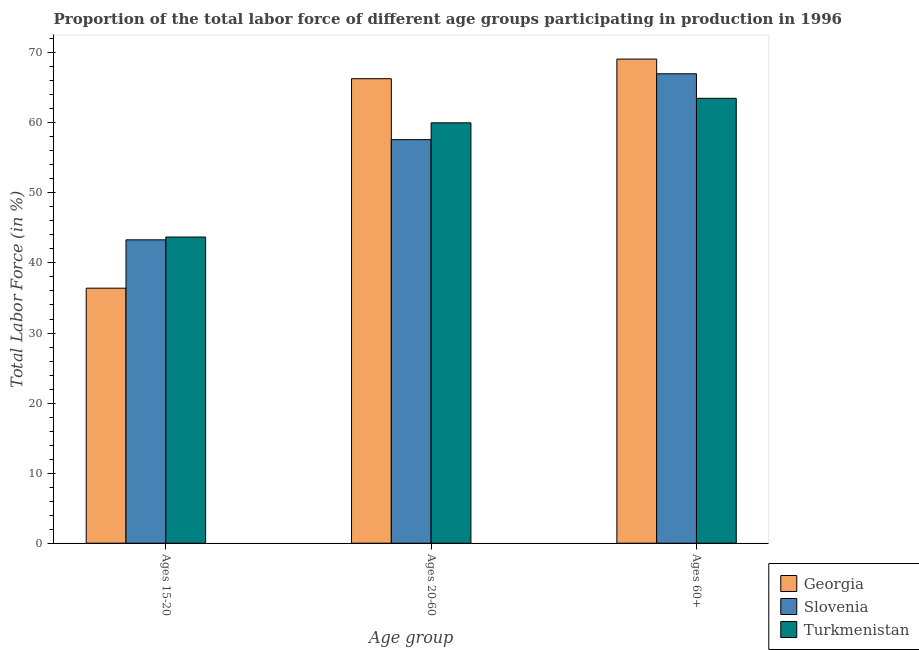How many bars are there on the 2nd tick from the left?
Give a very brief answer. 3. What is the label of the 1st group of bars from the left?
Keep it short and to the point. Ages 15-20. What is the percentage of labor force above age 60 in Turkmenistan?
Your answer should be very brief. 63.5. Across all countries, what is the maximum percentage of labor force within the age group 20-60?
Provide a succinct answer. 66.3. Across all countries, what is the minimum percentage of labor force within the age group 15-20?
Offer a very short reply. 36.4. In which country was the percentage of labor force within the age group 20-60 maximum?
Your answer should be very brief. Georgia. In which country was the percentage of labor force above age 60 minimum?
Provide a short and direct response. Turkmenistan. What is the total percentage of labor force above age 60 in the graph?
Keep it short and to the point. 199.6. What is the difference between the percentage of labor force within the age group 15-20 in Turkmenistan and that in Georgia?
Give a very brief answer. 7.3. What is the difference between the percentage of labor force within the age group 15-20 in Georgia and the percentage of labor force above age 60 in Turkmenistan?
Provide a short and direct response. -27.1. What is the average percentage of labor force within the age group 20-60 per country?
Keep it short and to the point. 61.3. What is the ratio of the percentage of labor force above age 60 in Slovenia to that in Turkmenistan?
Offer a terse response. 1.06. What is the difference between the highest and the second highest percentage of labor force within the age group 20-60?
Your answer should be compact. 6.3. What is the difference between the highest and the lowest percentage of labor force above age 60?
Your answer should be very brief. 5.6. Is the sum of the percentage of labor force within the age group 15-20 in Turkmenistan and Georgia greater than the maximum percentage of labor force within the age group 20-60 across all countries?
Offer a very short reply. Yes. What does the 3rd bar from the left in Ages 20-60 represents?
Make the answer very short. Turkmenistan. What does the 1st bar from the right in Ages 60+ represents?
Make the answer very short. Turkmenistan. Is it the case that in every country, the sum of the percentage of labor force within the age group 15-20 and percentage of labor force within the age group 20-60 is greater than the percentage of labor force above age 60?
Offer a very short reply. Yes. How many bars are there?
Your answer should be very brief. 9. How many countries are there in the graph?
Your response must be concise. 3. Are the values on the major ticks of Y-axis written in scientific E-notation?
Offer a very short reply. No. Does the graph contain any zero values?
Offer a very short reply. No. Does the graph contain grids?
Your answer should be very brief. No. How are the legend labels stacked?
Keep it short and to the point. Vertical. What is the title of the graph?
Ensure brevity in your answer.  Proportion of the total labor force of different age groups participating in production in 1996. Does "Other small states" appear as one of the legend labels in the graph?
Ensure brevity in your answer.  No. What is the label or title of the X-axis?
Your answer should be compact. Age group. What is the label or title of the Y-axis?
Your response must be concise. Total Labor Force (in %). What is the Total Labor Force (in %) of Georgia in Ages 15-20?
Give a very brief answer. 36.4. What is the Total Labor Force (in %) of Slovenia in Ages 15-20?
Offer a very short reply. 43.3. What is the Total Labor Force (in %) of Turkmenistan in Ages 15-20?
Offer a terse response. 43.7. What is the Total Labor Force (in %) of Georgia in Ages 20-60?
Provide a succinct answer. 66.3. What is the Total Labor Force (in %) of Slovenia in Ages 20-60?
Give a very brief answer. 57.6. What is the Total Labor Force (in %) of Turkmenistan in Ages 20-60?
Give a very brief answer. 60. What is the Total Labor Force (in %) of Georgia in Ages 60+?
Give a very brief answer. 69.1. What is the Total Labor Force (in %) of Turkmenistan in Ages 60+?
Your response must be concise. 63.5. Across all Age group, what is the maximum Total Labor Force (in %) in Georgia?
Offer a very short reply. 69.1. Across all Age group, what is the maximum Total Labor Force (in %) of Slovenia?
Make the answer very short. 67. Across all Age group, what is the maximum Total Labor Force (in %) of Turkmenistan?
Your answer should be compact. 63.5. Across all Age group, what is the minimum Total Labor Force (in %) in Georgia?
Offer a terse response. 36.4. Across all Age group, what is the minimum Total Labor Force (in %) in Slovenia?
Your answer should be very brief. 43.3. Across all Age group, what is the minimum Total Labor Force (in %) in Turkmenistan?
Give a very brief answer. 43.7. What is the total Total Labor Force (in %) in Georgia in the graph?
Give a very brief answer. 171.8. What is the total Total Labor Force (in %) of Slovenia in the graph?
Keep it short and to the point. 167.9. What is the total Total Labor Force (in %) of Turkmenistan in the graph?
Offer a very short reply. 167.2. What is the difference between the Total Labor Force (in %) in Georgia in Ages 15-20 and that in Ages 20-60?
Give a very brief answer. -29.9. What is the difference between the Total Labor Force (in %) of Slovenia in Ages 15-20 and that in Ages 20-60?
Your answer should be compact. -14.3. What is the difference between the Total Labor Force (in %) of Turkmenistan in Ages 15-20 and that in Ages 20-60?
Offer a very short reply. -16.3. What is the difference between the Total Labor Force (in %) of Georgia in Ages 15-20 and that in Ages 60+?
Provide a succinct answer. -32.7. What is the difference between the Total Labor Force (in %) in Slovenia in Ages 15-20 and that in Ages 60+?
Provide a succinct answer. -23.7. What is the difference between the Total Labor Force (in %) of Turkmenistan in Ages 15-20 and that in Ages 60+?
Your answer should be compact. -19.8. What is the difference between the Total Labor Force (in %) of Turkmenistan in Ages 20-60 and that in Ages 60+?
Ensure brevity in your answer.  -3.5. What is the difference between the Total Labor Force (in %) in Georgia in Ages 15-20 and the Total Labor Force (in %) in Slovenia in Ages 20-60?
Your response must be concise. -21.2. What is the difference between the Total Labor Force (in %) in Georgia in Ages 15-20 and the Total Labor Force (in %) in Turkmenistan in Ages 20-60?
Your answer should be very brief. -23.6. What is the difference between the Total Labor Force (in %) in Slovenia in Ages 15-20 and the Total Labor Force (in %) in Turkmenistan in Ages 20-60?
Your response must be concise. -16.7. What is the difference between the Total Labor Force (in %) of Georgia in Ages 15-20 and the Total Labor Force (in %) of Slovenia in Ages 60+?
Give a very brief answer. -30.6. What is the difference between the Total Labor Force (in %) in Georgia in Ages 15-20 and the Total Labor Force (in %) in Turkmenistan in Ages 60+?
Provide a short and direct response. -27.1. What is the difference between the Total Labor Force (in %) in Slovenia in Ages 15-20 and the Total Labor Force (in %) in Turkmenistan in Ages 60+?
Provide a short and direct response. -20.2. What is the difference between the Total Labor Force (in %) in Georgia in Ages 20-60 and the Total Labor Force (in %) in Slovenia in Ages 60+?
Offer a very short reply. -0.7. What is the difference between the Total Labor Force (in %) of Slovenia in Ages 20-60 and the Total Labor Force (in %) of Turkmenistan in Ages 60+?
Give a very brief answer. -5.9. What is the average Total Labor Force (in %) in Georgia per Age group?
Offer a very short reply. 57.27. What is the average Total Labor Force (in %) of Slovenia per Age group?
Your answer should be very brief. 55.97. What is the average Total Labor Force (in %) in Turkmenistan per Age group?
Your answer should be very brief. 55.73. What is the difference between the Total Labor Force (in %) of Slovenia and Total Labor Force (in %) of Turkmenistan in Ages 15-20?
Offer a very short reply. -0.4. What is the difference between the Total Labor Force (in %) of Georgia and Total Labor Force (in %) of Turkmenistan in Ages 20-60?
Ensure brevity in your answer.  6.3. What is the difference between the Total Labor Force (in %) in Slovenia and Total Labor Force (in %) in Turkmenistan in Ages 20-60?
Your answer should be very brief. -2.4. What is the difference between the Total Labor Force (in %) of Slovenia and Total Labor Force (in %) of Turkmenistan in Ages 60+?
Give a very brief answer. 3.5. What is the ratio of the Total Labor Force (in %) of Georgia in Ages 15-20 to that in Ages 20-60?
Provide a succinct answer. 0.55. What is the ratio of the Total Labor Force (in %) in Slovenia in Ages 15-20 to that in Ages 20-60?
Your answer should be compact. 0.75. What is the ratio of the Total Labor Force (in %) of Turkmenistan in Ages 15-20 to that in Ages 20-60?
Give a very brief answer. 0.73. What is the ratio of the Total Labor Force (in %) in Georgia in Ages 15-20 to that in Ages 60+?
Offer a very short reply. 0.53. What is the ratio of the Total Labor Force (in %) of Slovenia in Ages 15-20 to that in Ages 60+?
Keep it short and to the point. 0.65. What is the ratio of the Total Labor Force (in %) of Turkmenistan in Ages 15-20 to that in Ages 60+?
Provide a short and direct response. 0.69. What is the ratio of the Total Labor Force (in %) of Georgia in Ages 20-60 to that in Ages 60+?
Provide a short and direct response. 0.96. What is the ratio of the Total Labor Force (in %) of Slovenia in Ages 20-60 to that in Ages 60+?
Keep it short and to the point. 0.86. What is the ratio of the Total Labor Force (in %) in Turkmenistan in Ages 20-60 to that in Ages 60+?
Offer a terse response. 0.94. What is the difference between the highest and the second highest Total Labor Force (in %) of Slovenia?
Your answer should be very brief. 9.4. What is the difference between the highest and the second highest Total Labor Force (in %) in Turkmenistan?
Keep it short and to the point. 3.5. What is the difference between the highest and the lowest Total Labor Force (in %) of Georgia?
Make the answer very short. 32.7. What is the difference between the highest and the lowest Total Labor Force (in %) of Slovenia?
Provide a succinct answer. 23.7. What is the difference between the highest and the lowest Total Labor Force (in %) in Turkmenistan?
Provide a short and direct response. 19.8. 